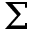<formula> <loc_0><loc_0><loc_500><loc_500>\Sigma</formula> 